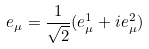<formula> <loc_0><loc_0><loc_500><loc_500>e _ { \mu } = \frac { 1 } { \sqrt { 2 } } ( e _ { \mu } ^ { 1 } + i e _ { \mu } ^ { 2 } )</formula> 